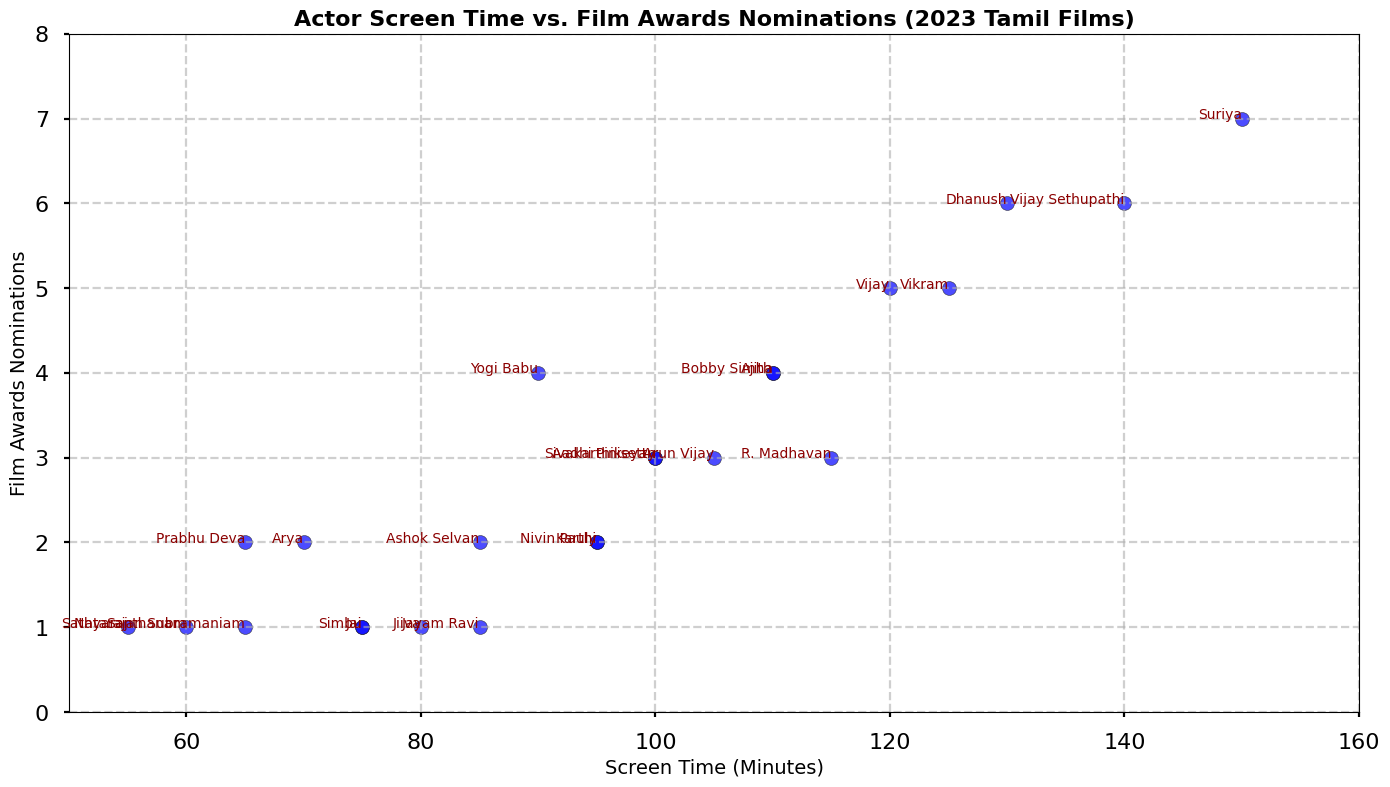Which actor has the highest screen time in the figure? By looking at the scatter plot, we can identify which actor's data point is the farthest to the right on the x-axis labeled "Screen Time (Minutes)." The actor associated with the highest x-axis value will have the highest screen time.
Answer: Suriya How many actors have a screen time of more than 120 minutes? Check the scatter plot for all the data points positioned to the right of the 120-minute mark on the x-axis. Count the number of these points to determine the number of actors with more than 120 minutes of screen time.
Answer: 3 Which two actors have the same number of award nominations but different screen times? Find the scatter plot points that share the same y-axis value (representing award nominations) but differ in their x-axis values (representing screen time). There are several potential points to examine, and one must cross-check between screen time and award nominations.
Answer: Vijay and Vikram What is the average screen time of the top three actors with the highest film awards nominations? Identify the top three actors with the most award nominations by looking at the highest points on the y-axis, which are Suriya, Dhanush, and Vijay Sethupathi. Sum their screen times: 150 + 130 + 140 = 420. Divide by 3 to find the average. (420 / 3 = 140)
Answer: 140 Which actor has the shortest screen time with award nominations of exactly 3? Look for the scatter plot points that correspond to an exact y-axis value of 3 and then find the point with the lowest x-axis value, indicating the shortest screen time.
Answer: R. Madhavan Comparing Ajith and Vijay Sethupathi, who has more film award nominations and by how many? Find the y-axis values for Ajith and Vijay Sethupathi. The points show respectively: 4 and 6. Subtract the smaller from the larger (6 - 4 = 2).
Answer: Vijay Sethupathi by 2 What is the total combined screen time of actors with award nominations of 2? Locate all data points with a y-axis value of 2 and sum their respective x-axis values: Karthi (95), Arya (70), Prabhu Deva (65), Ashok Selvan (85), Nivin Pauly (95). Sum these values: 95 + 70 + 65 + 85 + 95 = 410.
Answer: 410 Which actor with a screen time above 100 minutes has the least number of award nominations? Check all the data points with x-axis values greater than 100 and find the point with the lowest y-axis value among them. This involves selecting the minimum value from the subset.
Answer: Arun Vijay Is there a correlation between screen time and film award nominations? If so, what type of correlation is it? To determine the correlation type, visually inspect the trend of the scatter plot points. If they generally rise together, it's a positive correlation; if they decrease together, it's negative. The scatter plot shows that as screen time increases, the number of nominations tends to increase.
Answer: Positive correlation 